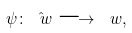Convert formula to latex. <formula><loc_0><loc_0><loc_500><loc_500>\psi \colon \hat { \ w } \longrightarrow \ w ,</formula> 